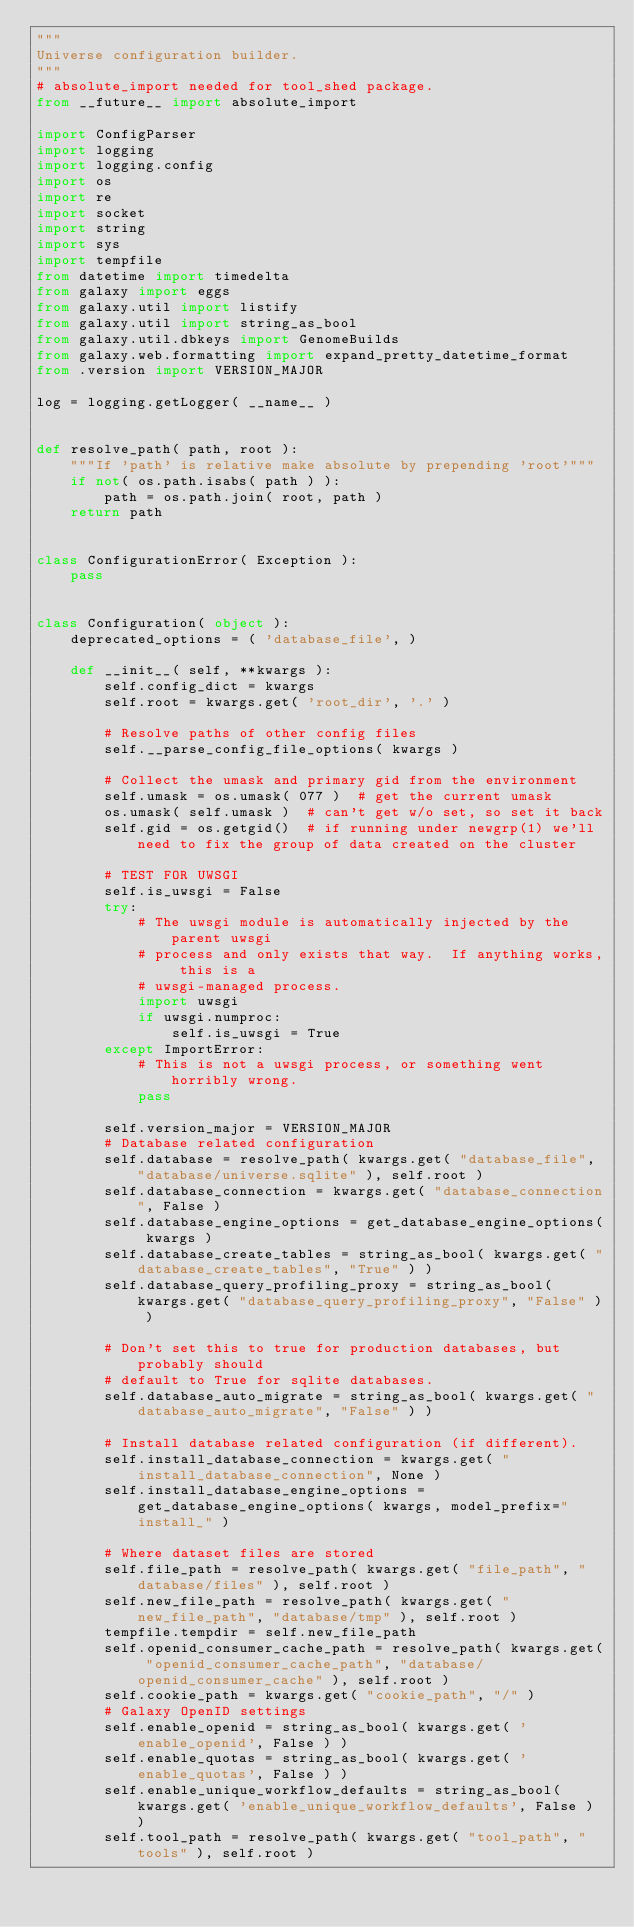Convert code to text. <code><loc_0><loc_0><loc_500><loc_500><_Python_>"""
Universe configuration builder.
"""
# absolute_import needed for tool_shed package.
from __future__ import absolute_import

import ConfigParser
import logging
import logging.config
import os
import re
import socket
import string
import sys
import tempfile
from datetime import timedelta
from galaxy import eggs
from galaxy.util import listify
from galaxy.util import string_as_bool
from galaxy.util.dbkeys import GenomeBuilds
from galaxy.web.formatting import expand_pretty_datetime_format
from .version import VERSION_MAJOR

log = logging.getLogger( __name__ )


def resolve_path( path, root ):
    """If 'path' is relative make absolute by prepending 'root'"""
    if not( os.path.isabs( path ) ):
        path = os.path.join( root, path )
    return path


class ConfigurationError( Exception ):
    pass


class Configuration( object ):
    deprecated_options = ( 'database_file', )

    def __init__( self, **kwargs ):
        self.config_dict = kwargs
        self.root = kwargs.get( 'root_dir', '.' )

        # Resolve paths of other config files
        self.__parse_config_file_options( kwargs )

        # Collect the umask and primary gid from the environment
        self.umask = os.umask( 077 )  # get the current umask
        os.umask( self.umask )  # can't get w/o set, so set it back
        self.gid = os.getgid()  # if running under newgrp(1) we'll need to fix the group of data created on the cluster

        # TEST FOR UWSGI
        self.is_uwsgi = False
        try:
            # The uwsgi module is automatically injected by the parent uwsgi
            # process and only exists that way.  If anything works, this is a
            # uwsgi-managed process.
            import uwsgi
            if uwsgi.numproc:
                self.is_uwsgi = True
        except ImportError:
            # This is not a uwsgi process, or something went horribly wrong.
            pass

        self.version_major = VERSION_MAJOR
        # Database related configuration
        self.database = resolve_path( kwargs.get( "database_file", "database/universe.sqlite" ), self.root )
        self.database_connection = kwargs.get( "database_connection", False )
        self.database_engine_options = get_database_engine_options( kwargs )
        self.database_create_tables = string_as_bool( kwargs.get( "database_create_tables", "True" ) )
        self.database_query_profiling_proxy = string_as_bool( kwargs.get( "database_query_profiling_proxy", "False" ) )

        # Don't set this to true for production databases, but probably should
        # default to True for sqlite databases.
        self.database_auto_migrate = string_as_bool( kwargs.get( "database_auto_migrate", "False" ) )

        # Install database related configuration (if different).
        self.install_database_connection = kwargs.get( "install_database_connection", None )
        self.install_database_engine_options = get_database_engine_options( kwargs, model_prefix="install_" )

        # Where dataset files are stored
        self.file_path = resolve_path( kwargs.get( "file_path", "database/files" ), self.root )
        self.new_file_path = resolve_path( kwargs.get( "new_file_path", "database/tmp" ), self.root )
        tempfile.tempdir = self.new_file_path
        self.openid_consumer_cache_path = resolve_path( kwargs.get( "openid_consumer_cache_path", "database/openid_consumer_cache" ), self.root )
        self.cookie_path = kwargs.get( "cookie_path", "/" )
        # Galaxy OpenID settings
        self.enable_openid = string_as_bool( kwargs.get( 'enable_openid', False ) )
        self.enable_quotas = string_as_bool( kwargs.get( 'enable_quotas', False ) )
        self.enable_unique_workflow_defaults = string_as_bool( kwargs.get( 'enable_unique_workflow_defaults', False ) )
        self.tool_path = resolve_path( kwargs.get( "tool_path", "tools" ), self.root )</code> 